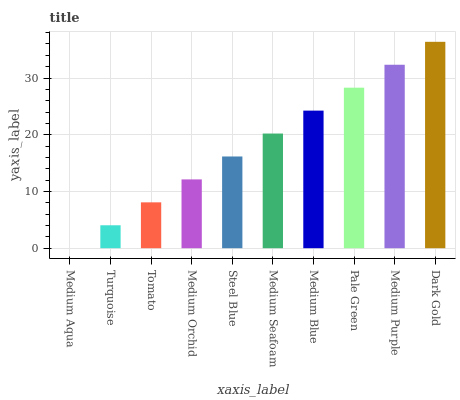Is Medium Aqua the minimum?
Answer yes or no. Yes. Is Dark Gold the maximum?
Answer yes or no. Yes. Is Turquoise the minimum?
Answer yes or no. No. Is Turquoise the maximum?
Answer yes or no. No. Is Turquoise greater than Medium Aqua?
Answer yes or no. Yes. Is Medium Aqua less than Turquoise?
Answer yes or no. Yes. Is Medium Aqua greater than Turquoise?
Answer yes or no. No. Is Turquoise less than Medium Aqua?
Answer yes or no. No. Is Medium Seafoam the high median?
Answer yes or no. Yes. Is Steel Blue the low median?
Answer yes or no. Yes. Is Steel Blue the high median?
Answer yes or no. No. Is Medium Blue the low median?
Answer yes or no. No. 